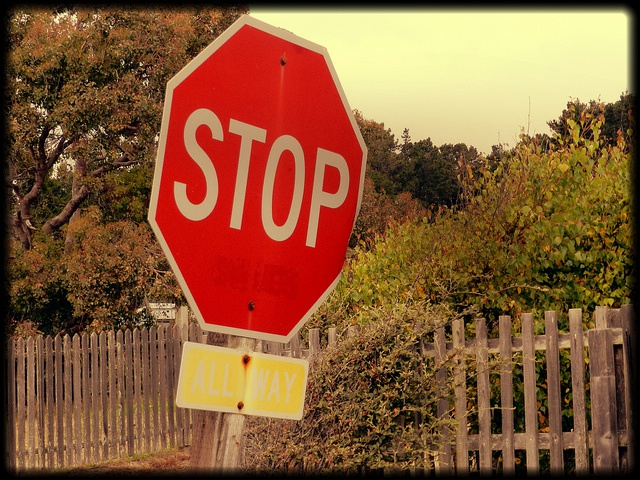Describe the objects in this image and their specific colors. I can see a stop sign in black, brown, and tan tones in this image. 